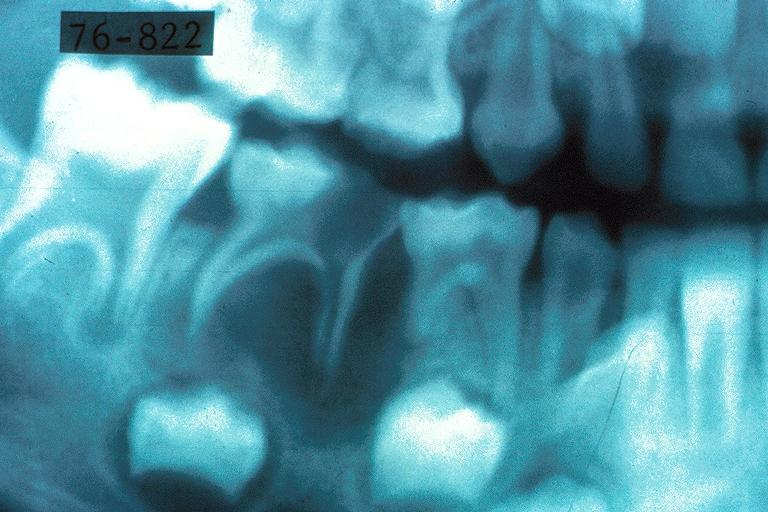s vasculitis foreign body present?
Answer the question using a single word or phrase. No 